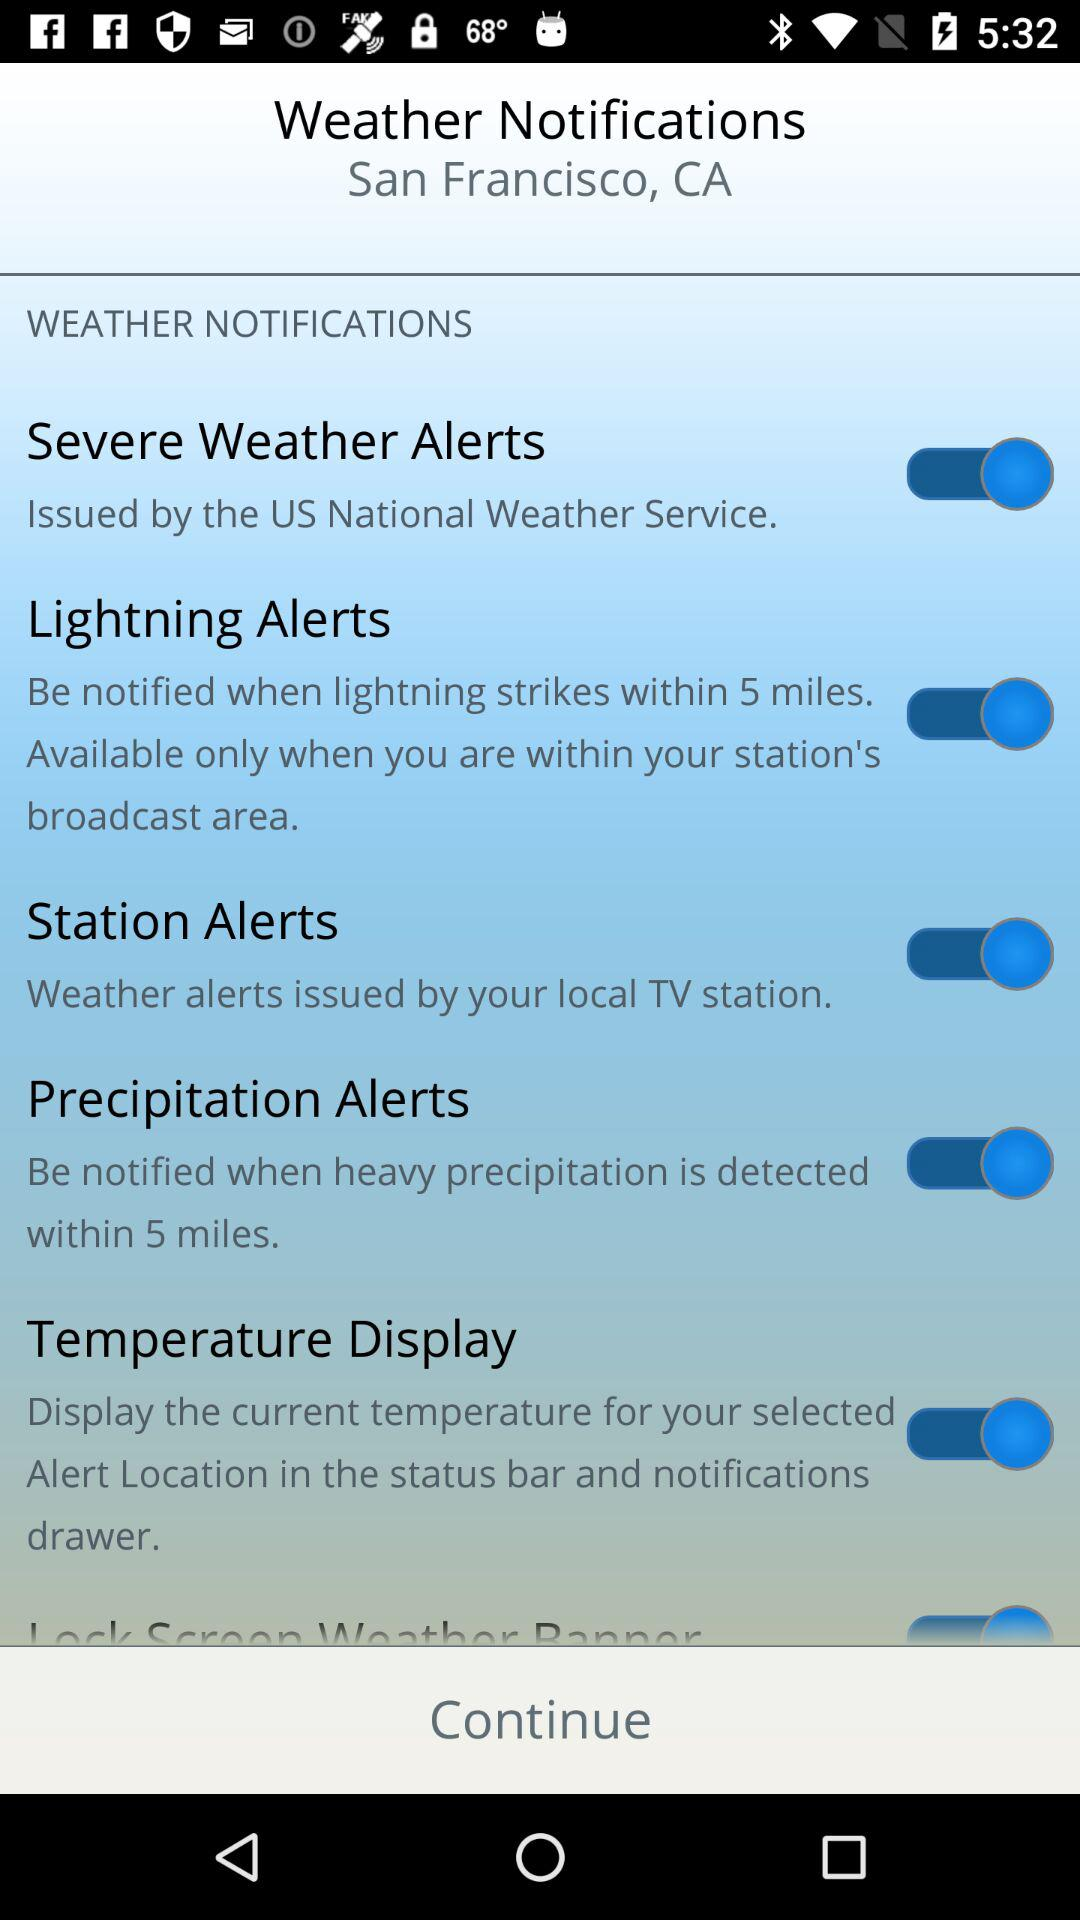Within how many miles will a lightning strike be notified? A lightning strike is notified within 5 miles. 